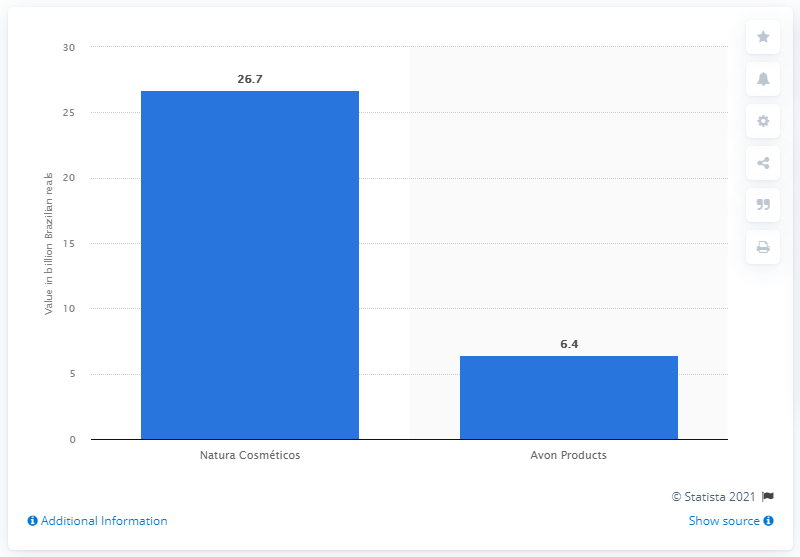Indicate a few pertinent items in this graphic. The market value of Natura Cosmeticos was 26.7 billion reals in 2019. The market capitalization value of Avon Products was 6.4 on [date]. 